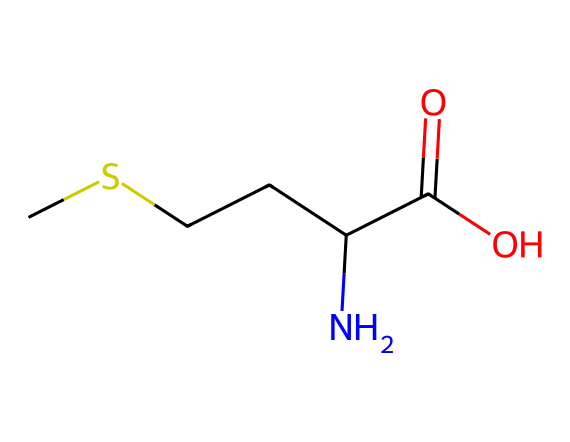How many carbon atoms are in methionine? The SMILES representation shows "CSCCC," indicating there are five carbon atoms in total. The "C" represents carbon, and each "C" in the chain contributes one carbon atom.
Answer: five What is the functional group present in methionine? The carboxylic acid group is represented as "C(=O)O" in the structure, where "C(=O)" signifies a carbon double-bonded to oxygen and also bonded to a hydroxyl group "O." This group is characteristic of acids.
Answer: carboxylic acid How many nitrogen atoms are in methionine? The structure includes one "N" that is part of the amine group "C(N)," indicating that there is a single nitrogen atom present in the molecule.
Answer: one Which part of methionine contributes to its organosulfur classification? The sulfur atom is denoted by the "S" in the initial part of the SMILES, specifically in "CS," indicating the presence of a sulfur atom, typical for organosulfur compounds.
Answer: sulfur What is the total number of hydrogen atoms in methionine? By analyzing the structure, we can count the attached hydrogen atoms. There are 11 hydrogens in total based on the tetravalency of carbon and the valency of the other atoms. The nitrogen and sulfur also contribute to this total.
Answer: eleven What is the significance of methionine in metabolism? Methionine plays a crucial role as an essential amino acid that serves as a precursor for other important molecules, including the methyl donor S-adenosyl methionine, linking it directly to metabolic processes.
Answer: essential amino acid 